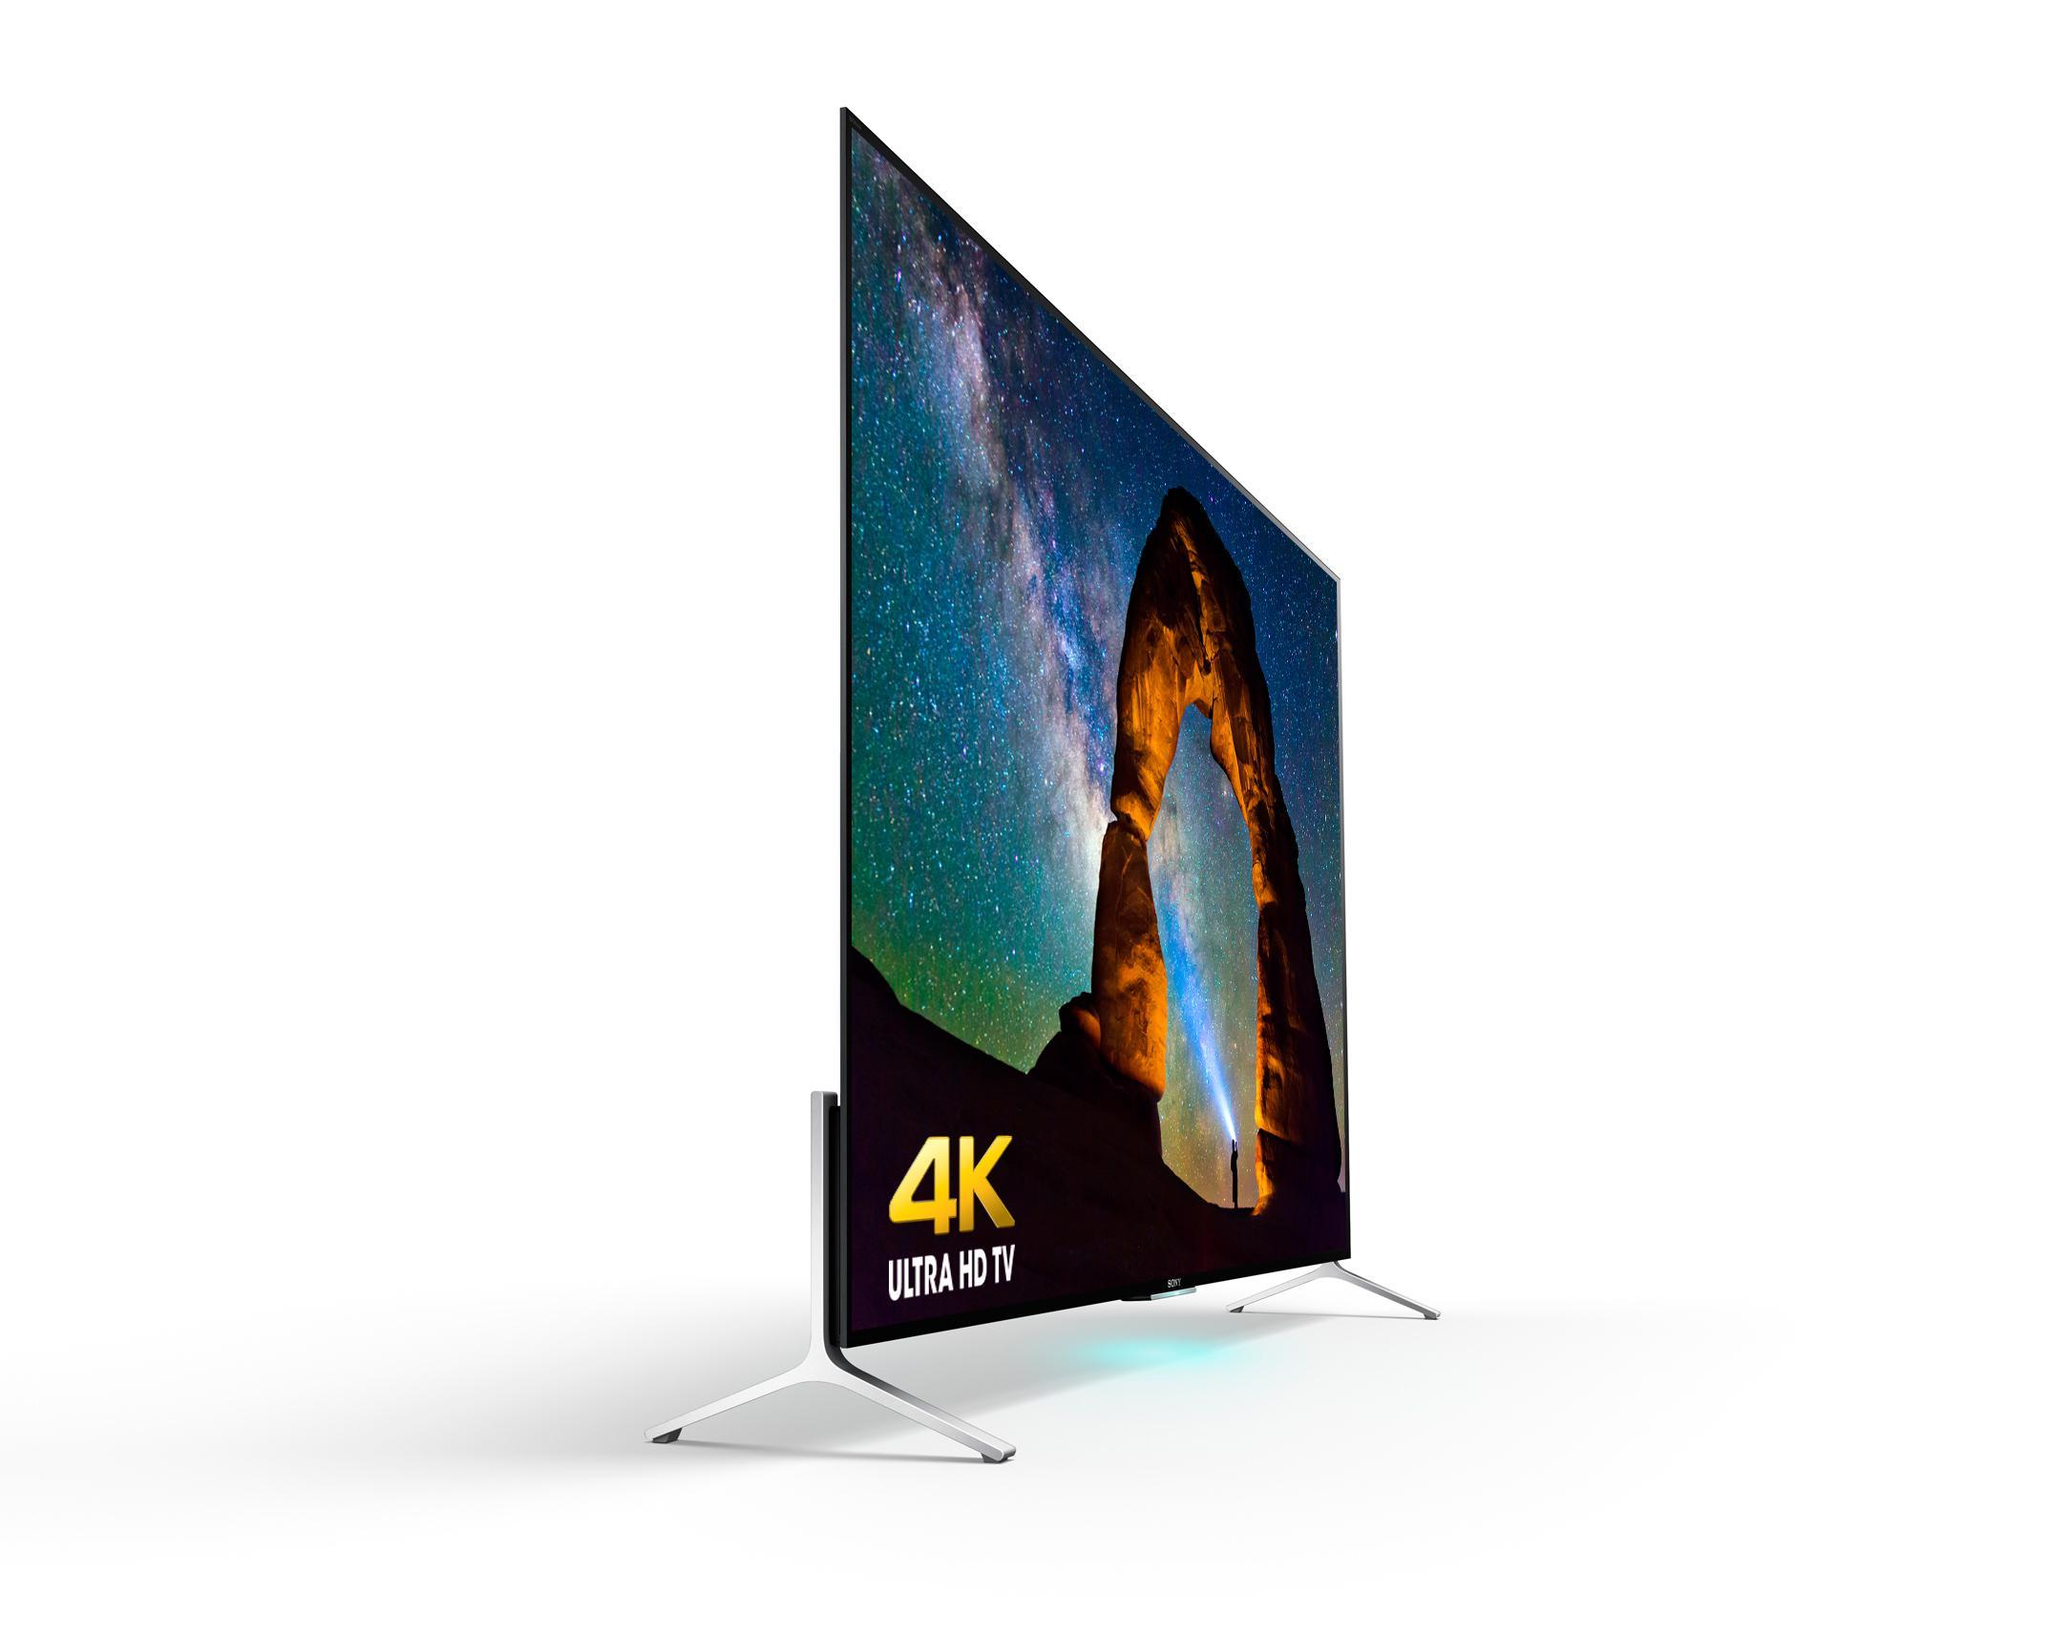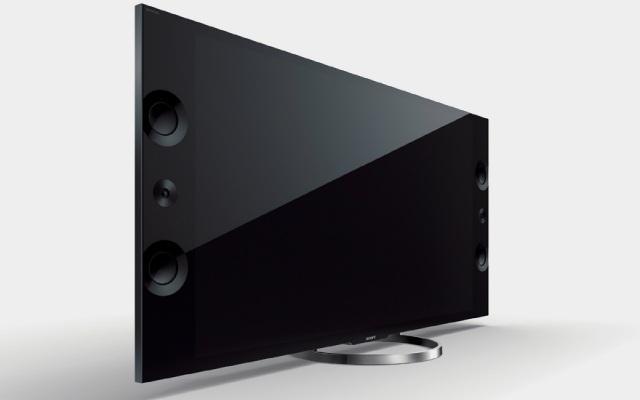The first image is the image on the left, the second image is the image on the right. Evaluate the accuracy of this statement regarding the images: "In one of the images, the TV is showing a colorful display.". Is it true? Answer yes or no. Yes. The first image is the image on the left, the second image is the image on the right. For the images shown, is this caption "Each image shows one black-screened TV elevated by chrome legs." true? Answer yes or no. No. 